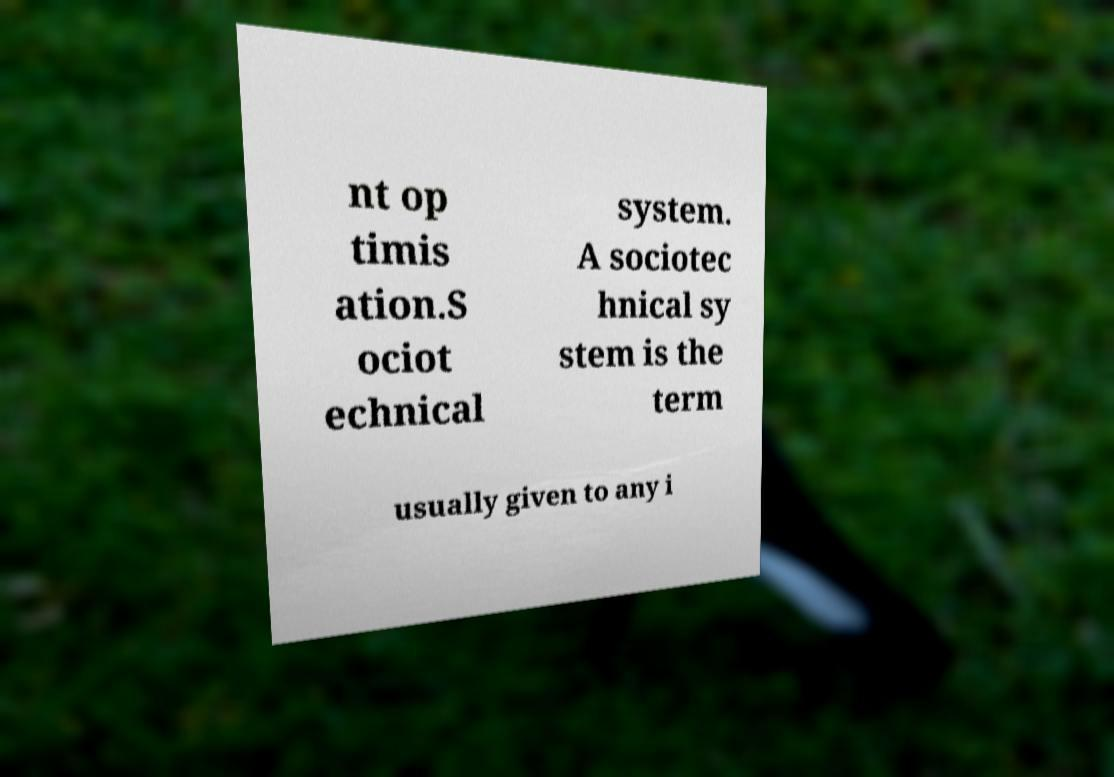For documentation purposes, I need the text within this image transcribed. Could you provide that? nt op timis ation.S ociot echnical system. A sociotec hnical sy stem is the term usually given to any i 